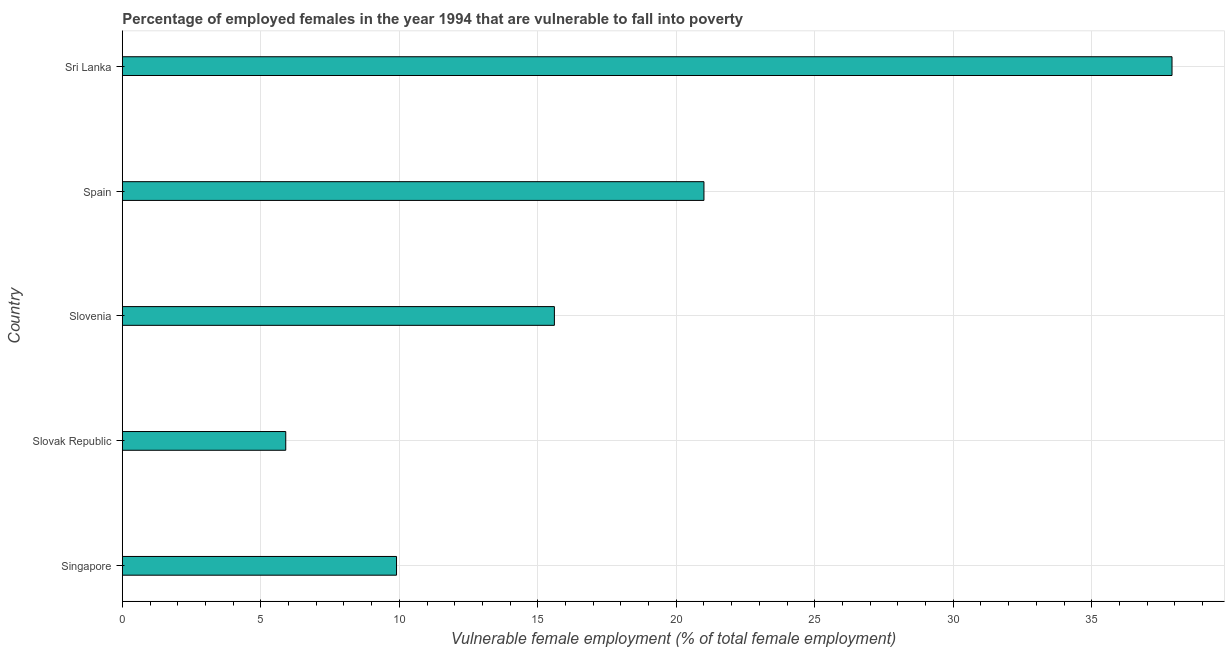Does the graph contain grids?
Make the answer very short. Yes. What is the title of the graph?
Give a very brief answer. Percentage of employed females in the year 1994 that are vulnerable to fall into poverty. What is the label or title of the X-axis?
Give a very brief answer. Vulnerable female employment (% of total female employment). What is the label or title of the Y-axis?
Your answer should be compact. Country. What is the percentage of employed females who are vulnerable to fall into poverty in Slovenia?
Ensure brevity in your answer.  15.6. Across all countries, what is the maximum percentage of employed females who are vulnerable to fall into poverty?
Give a very brief answer. 37.9. Across all countries, what is the minimum percentage of employed females who are vulnerable to fall into poverty?
Your answer should be very brief. 5.9. In which country was the percentage of employed females who are vulnerable to fall into poverty maximum?
Provide a succinct answer. Sri Lanka. In which country was the percentage of employed females who are vulnerable to fall into poverty minimum?
Provide a short and direct response. Slovak Republic. What is the sum of the percentage of employed females who are vulnerable to fall into poverty?
Your response must be concise. 90.3. What is the difference between the percentage of employed females who are vulnerable to fall into poverty in Spain and Sri Lanka?
Ensure brevity in your answer.  -16.9. What is the average percentage of employed females who are vulnerable to fall into poverty per country?
Offer a very short reply. 18.06. What is the median percentage of employed females who are vulnerable to fall into poverty?
Offer a very short reply. 15.6. What is the ratio of the percentage of employed females who are vulnerable to fall into poverty in Slovenia to that in Sri Lanka?
Ensure brevity in your answer.  0.41. Is the sum of the percentage of employed females who are vulnerable to fall into poverty in Slovenia and Spain greater than the maximum percentage of employed females who are vulnerable to fall into poverty across all countries?
Your answer should be very brief. No. In how many countries, is the percentage of employed females who are vulnerable to fall into poverty greater than the average percentage of employed females who are vulnerable to fall into poverty taken over all countries?
Offer a terse response. 2. What is the difference between two consecutive major ticks on the X-axis?
Your answer should be compact. 5. Are the values on the major ticks of X-axis written in scientific E-notation?
Make the answer very short. No. What is the Vulnerable female employment (% of total female employment) in Singapore?
Keep it short and to the point. 9.9. What is the Vulnerable female employment (% of total female employment) in Slovak Republic?
Provide a short and direct response. 5.9. What is the Vulnerable female employment (% of total female employment) of Slovenia?
Give a very brief answer. 15.6. What is the Vulnerable female employment (% of total female employment) in Spain?
Keep it short and to the point. 21. What is the Vulnerable female employment (% of total female employment) in Sri Lanka?
Your response must be concise. 37.9. What is the difference between the Vulnerable female employment (% of total female employment) in Singapore and Slovak Republic?
Your answer should be compact. 4. What is the difference between the Vulnerable female employment (% of total female employment) in Singapore and Sri Lanka?
Provide a succinct answer. -28. What is the difference between the Vulnerable female employment (% of total female employment) in Slovak Republic and Slovenia?
Provide a succinct answer. -9.7. What is the difference between the Vulnerable female employment (% of total female employment) in Slovak Republic and Spain?
Your answer should be compact. -15.1. What is the difference between the Vulnerable female employment (% of total female employment) in Slovak Republic and Sri Lanka?
Make the answer very short. -32. What is the difference between the Vulnerable female employment (% of total female employment) in Slovenia and Sri Lanka?
Offer a terse response. -22.3. What is the difference between the Vulnerable female employment (% of total female employment) in Spain and Sri Lanka?
Give a very brief answer. -16.9. What is the ratio of the Vulnerable female employment (% of total female employment) in Singapore to that in Slovak Republic?
Your answer should be very brief. 1.68. What is the ratio of the Vulnerable female employment (% of total female employment) in Singapore to that in Slovenia?
Your answer should be very brief. 0.64. What is the ratio of the Vulnerable female employment (% of total female employment) in Singapore to that in Spain?
Your response must be concise. 0.47. What is the ratio of the Vulnerable female employment (% of total female employment) in Singapore to that in Sri Lanka?
Ensure brevity in your answer.  0.26. What is the ratio of the Vulnerable female employment (% of total female employment) in Slovak Republic to that in Slovenia?
Provide a succinct answer. 0.38. What is the ratio of the Vulnerable female employment (% of total female employment) in Slovak Republic to that in Spain?
Offer a terse response. 0.28. What is the ratio of the Vulnerable female employment (% of total female employment) in Slovak Republic to that in Sri Lanka?
Offer a very short reply. 0.16. What is the ratio of the Vulnerable female employment (% of total female employment) in Slovenia to that in Spain?
Provide a succinct answer. 0.74. What is the ratio of the Vulnerable female employment (% of total female employment) in Slovenia to that in Sri Lanka?
Your answer should be compact. 0.41. What is the ratio of the Vulnerable female employment (% of total female employment) in Spain to that in Sri Lanka?
Your response must be concise. 0.55. 